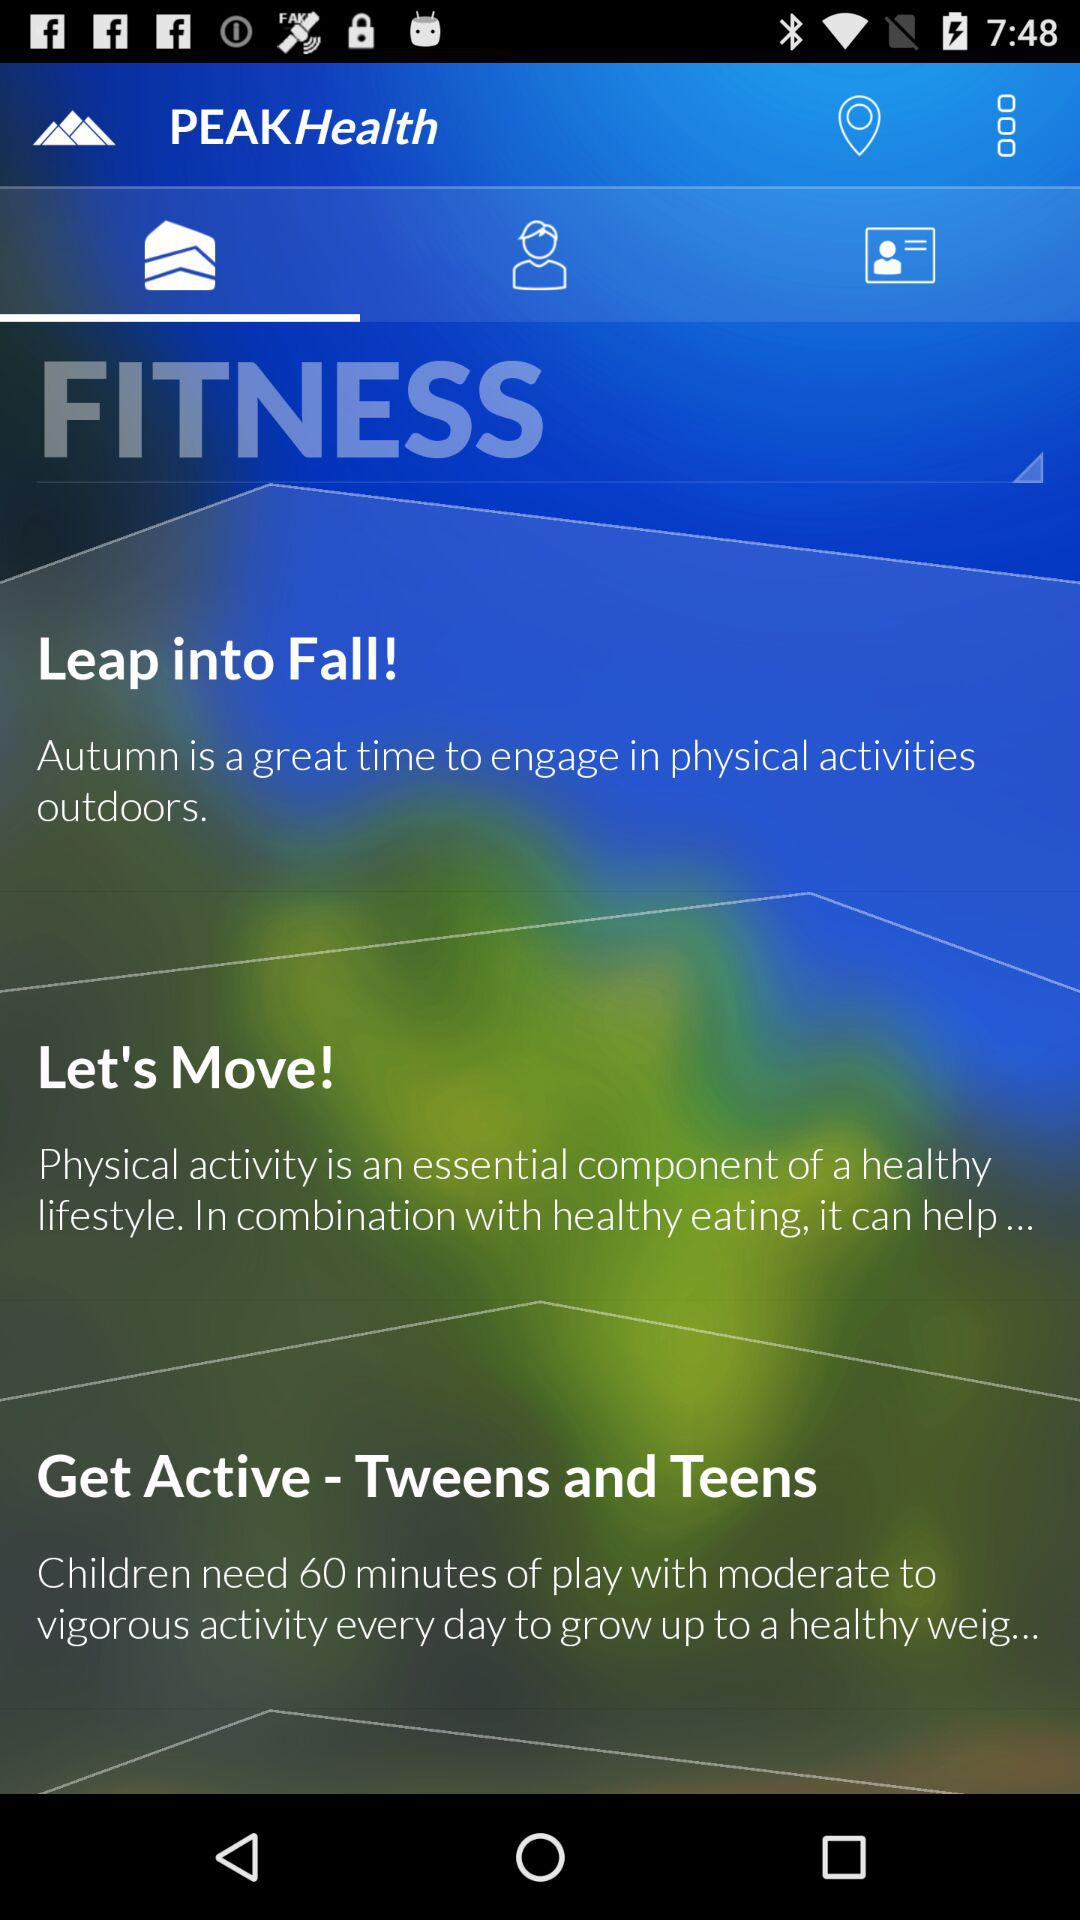What is a great time to engage in physical activity? A great time to engage in physical activity is autumn. 